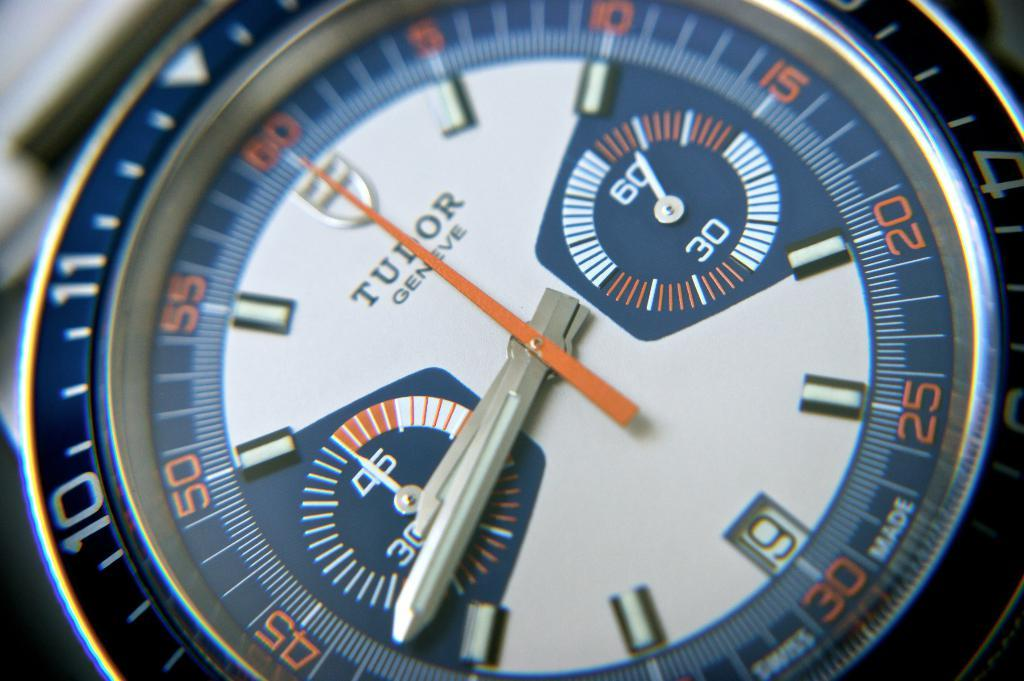<image>
Provide a brief description of the given image. A Tudor watch in the color blue has a number 10 on it. 